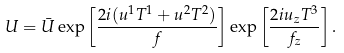<formula> <loc_0><loc_0><loc_500><loc_500>U = \bar { U } \exp \left [ \frac { 2 i ( u ^ { 1 } T ^ { 1 } + u ^ { 2 } T ^ { 2 } ) } { f } \right ] \exp \left [ \frac { 2 i u _ { z } T ^ { 3 } } { f _ { z } } \right ] .</formula> 